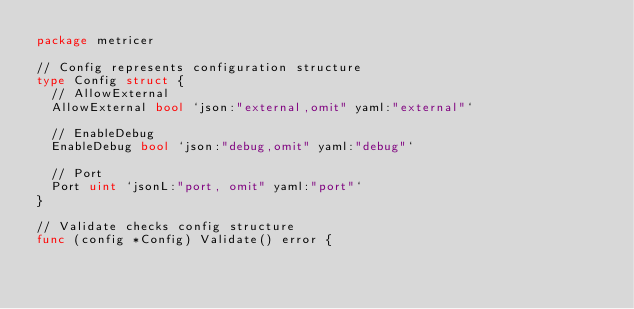Convert code to text. <code><loc_0><loc_0><loc_500><loc_500><_Go_>package metricer

// Config represents configuration structure
type Config struct {
	// AllowExternal
	AllowExternal bool `json:"external,omit" yaml:"external"`

	// EnableDebug
	EnableDebug bool `json:"debug,omit" yaml:"debug"`

	// Port
	Port uint `jsonL:"port, omit" yaml:"port"`
}

// Validate checks config structure
func (config *Config) Validate() error {</code> 